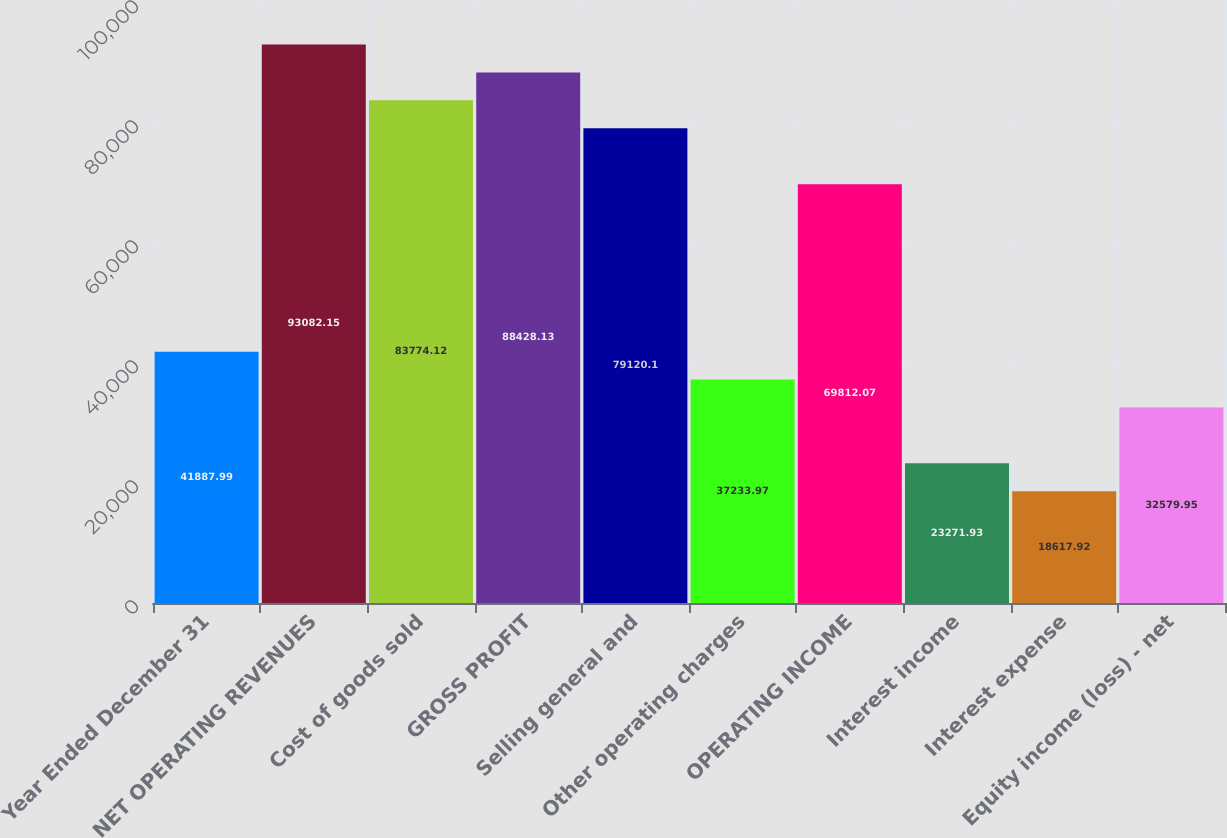<chart> <loc_0><loc_0><loc_500><loc_500><bar_chart><fcel>Year Ended December 31<fcel>NET OPERATING REVENUES<fcel>Cost of goods sold<fcel>GROSS PROFIT<fcel>Selling general and<fcel>Other operating charges<fcel>OPERATING INCOME<fcel>Interest income<fcel>Interest expense<fcel>Equity income (loss) - net<nl><fcel>41888<fcel>93082.1<fcel>83774.1<fcel>88428.1<fcel>79120.1<fcel>37234<fcel>69812.1<fcel>23271.9<fcel>18617.9<fcel>32580<nl></chart> 